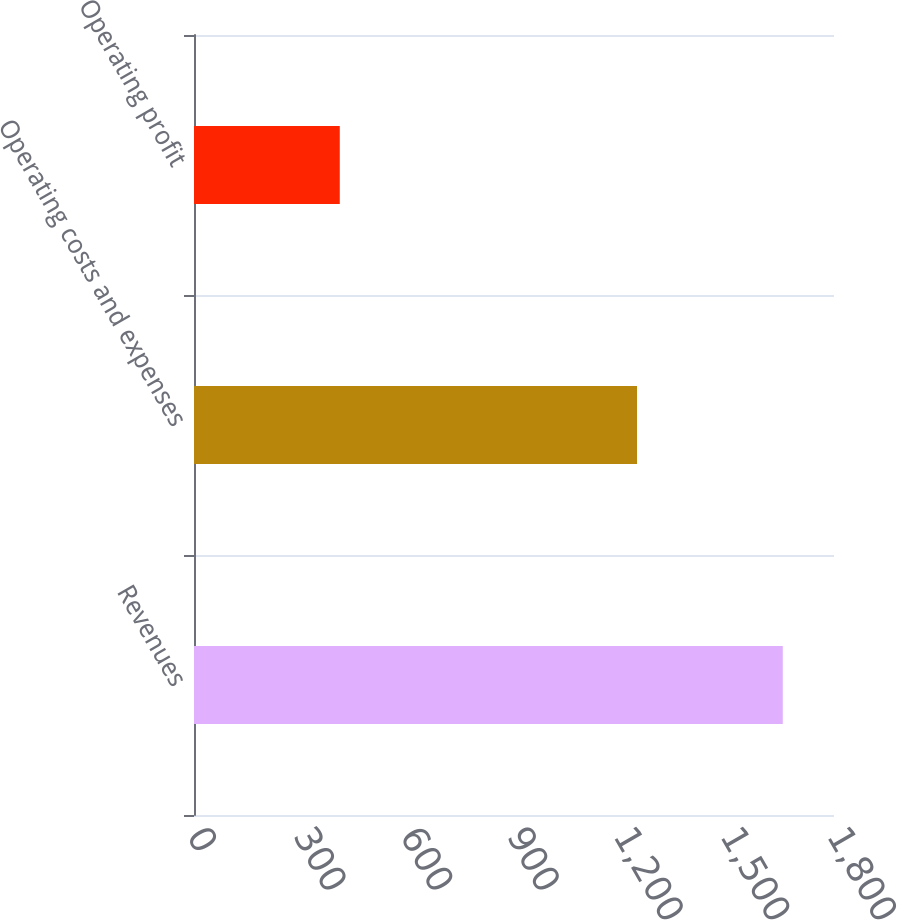Convert chart. <chart><loc_0><loc_0><loc_500><loc_500><bar_chart><fcel>Revenues<fcel>Operating costs and expenses<fcel>Operating profit<nl><fcel>1656<fcel>1246<fcel>410<nl></chart> 